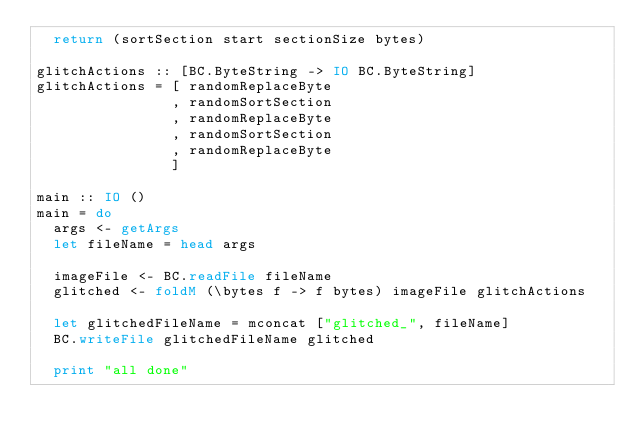Convert code to text. <code><loc_0><loc_0><loc_500><loc_500><_Haskell_>  return (sortSection start sectionSize bytes)

glitchActions :: [BC.ByteString -> IO BC.ByteString]
glitchActions = [ randomReplaceByte
                , randomSortSection
                , randomReplaceByte
                , randomSortSection
                , randomReplaceByte
                ]

main :: IO ()
main = do
  args <- getArgs
  let fileName = head args

  imageFile <- BC.readFile fileName
  glitched <- foldM (\bytes f -> f bytes) imageFile glitchActions

  let glitchedFileName = mconcat ["glitched_", fileName]
  BC.writeFile glitchedFileName glitched

  print "all done"
</code> 